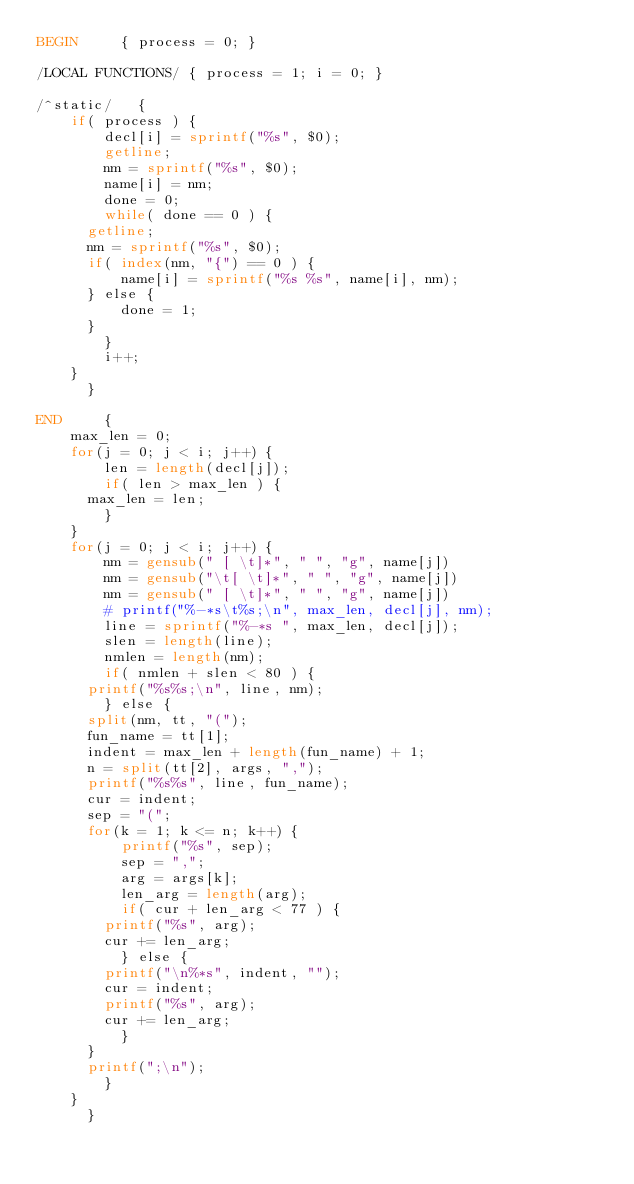<code> <loc_0><loc_0><loc_500><loc_500><_Awk_>BEGIN	    { process = 0; }

/LOCAL FUNCTIONS/ { process = 1; i = 0; }

/^static/   {
		if( process ) {
		    decl[i] = sprintf("%s", $0);
		    getline;
		    nm = sprintf("%s", $0);
		    name[i] = nm;
		    done = 0;
		    while( done == 0 ) {
			getline;
			nm = sprintf("%s", $0);
			if( index(nm, "{") == 0 ) {
			    name[i] = sprintf("%s %s", name[i], nm);
			} else {
			    done = 1;
			}
		    }
		    i++;
		}
	    }

END	    {
		max_len = 0;
		for(j = 0; j < i; j++) {
		    len = length(decl[j]);
		    if( len > max_len ) {
			max_len = len;
		    }
		}
		for(j = 0; j < i; j++) {
		    nm = gensub(" [ \t]*", " ", "g", name[j])
		    nm = gensub("\t[ \t]*", " ", "g", name[j])
		    nm = gensub(" [ \t]*", " ", "g", name[j])
		    # printf("%-*s\t%s;\n", max_len, decl[j], nm);
		    line = sprintf("%-*s ", max_len, decl[j]);
		    slen = length(line);
		    nmlen = length(nm);
		    if( nmlen + slen < 80 ) {
			printf("%s%s;\n", line, nm);
		    } else {
			split(nm, tt, "(");
			fun_name = tt[1];
			indent = max_len + length(fun_name) + 1;
			n = split(tt[2], args, ",");
			printf("%s%s", line, fun_name);
			cur = indent;
			sep = "(";
			for(k = 1; k <= n; k++) {
			    printf("%s", sep);
			    sep = ",";
			    arg = args[k];
			    len_arg = length(arg);
			    if( cur + len_arg < 77 ) {
				printf("%s", arg);
				cur += len_arg;
			    } else {
				printf("\n%*s", indent, "");
				cur = indent;
				printf("%s", arg);
				cur += len_arg;
			    }
			}
			printf(";\n");
		    }
		}
	    }
</code> 